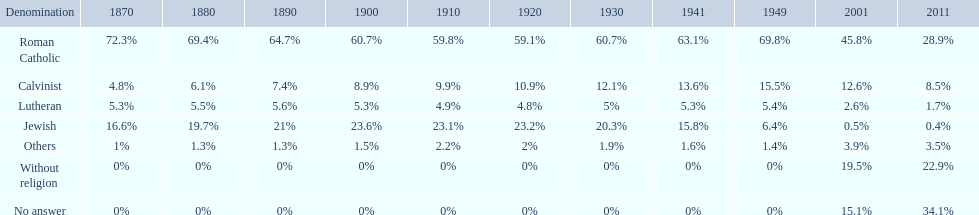What is the largest religious denomination in budapest? Roman Catholic. 